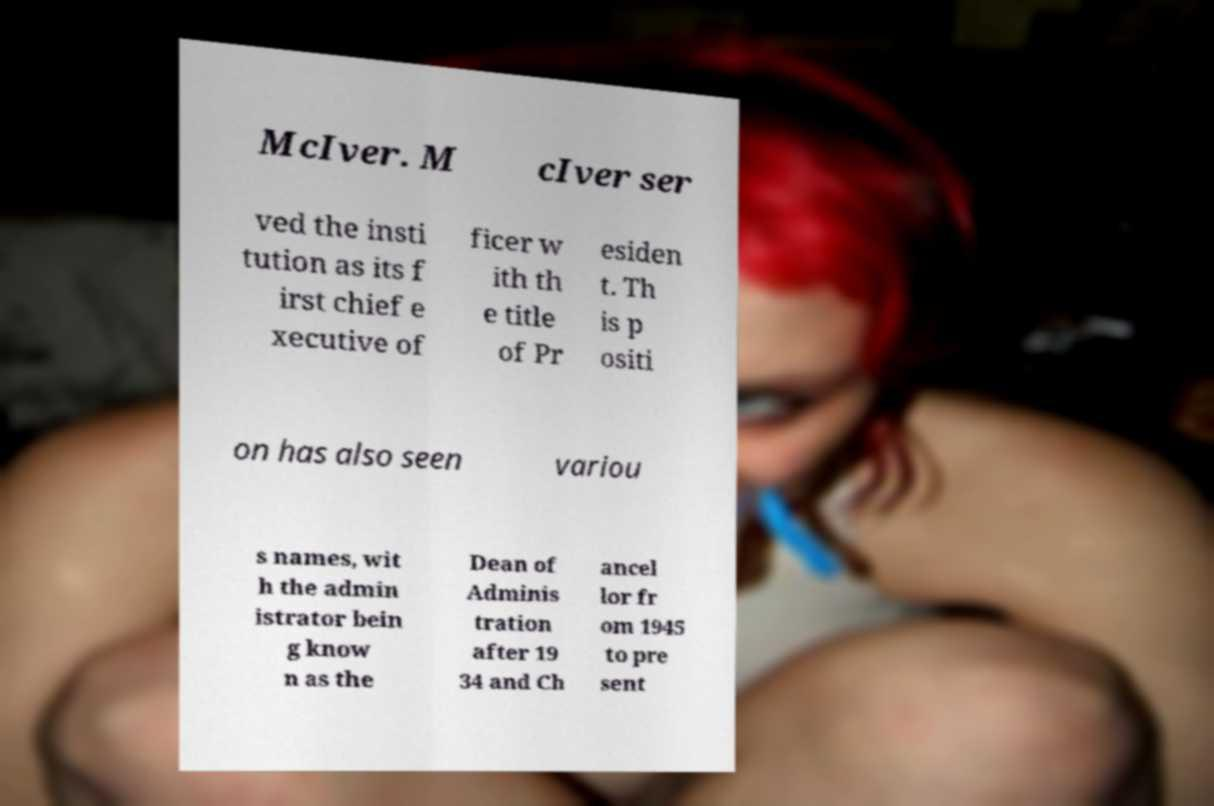Can you accurately transcribe the text from the provided image for me? McIver. M cIver ser ved the insti tution as its f irst chief e xecutive of ficer w ith th e title of Pr esiden t. Th is p ositi on has also seen variou s names, wit h the admin istrator bein g know n as the Dean of Adminis tration after 19 34 and Ch ancel lor fr om 1945 to pre sent 